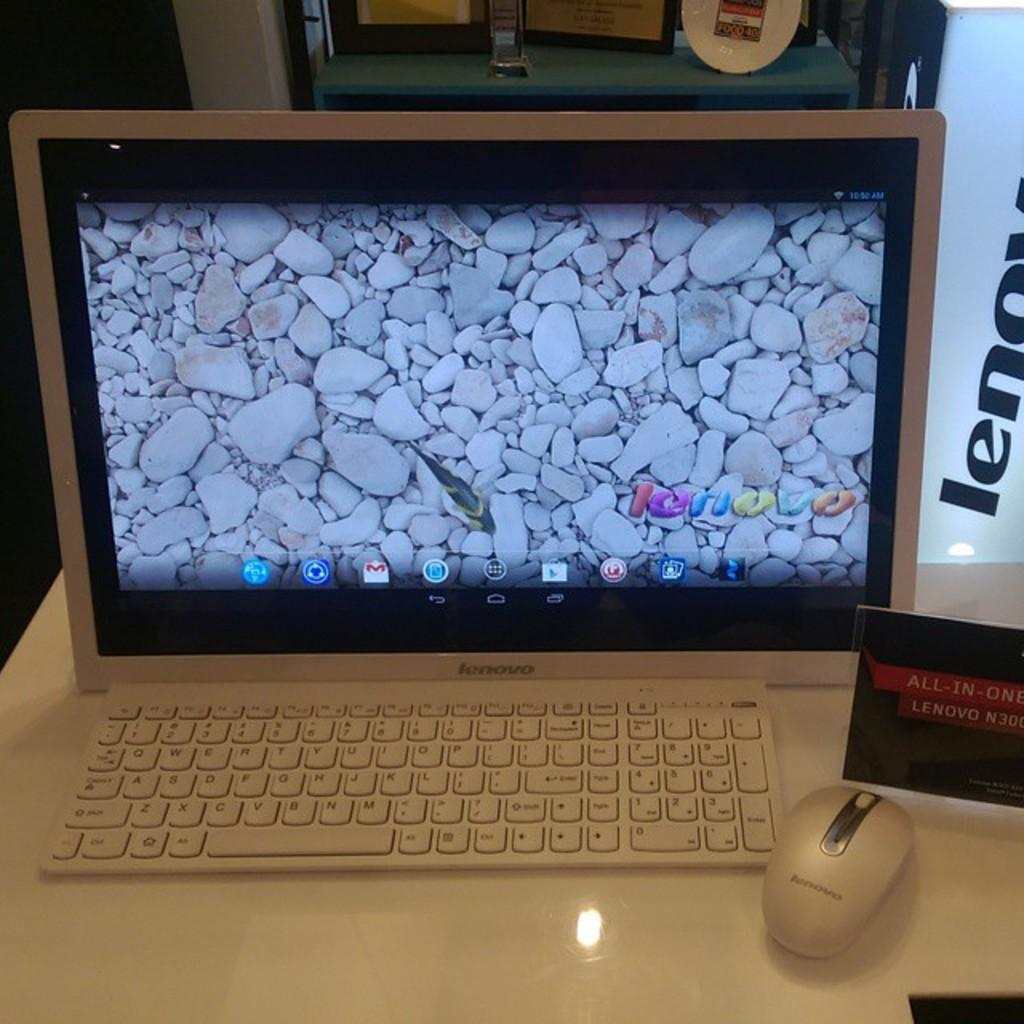<image>
Share a concise interpretation of the image provided. A lenovo desktop shows display of small rounded stones like on a coast. 